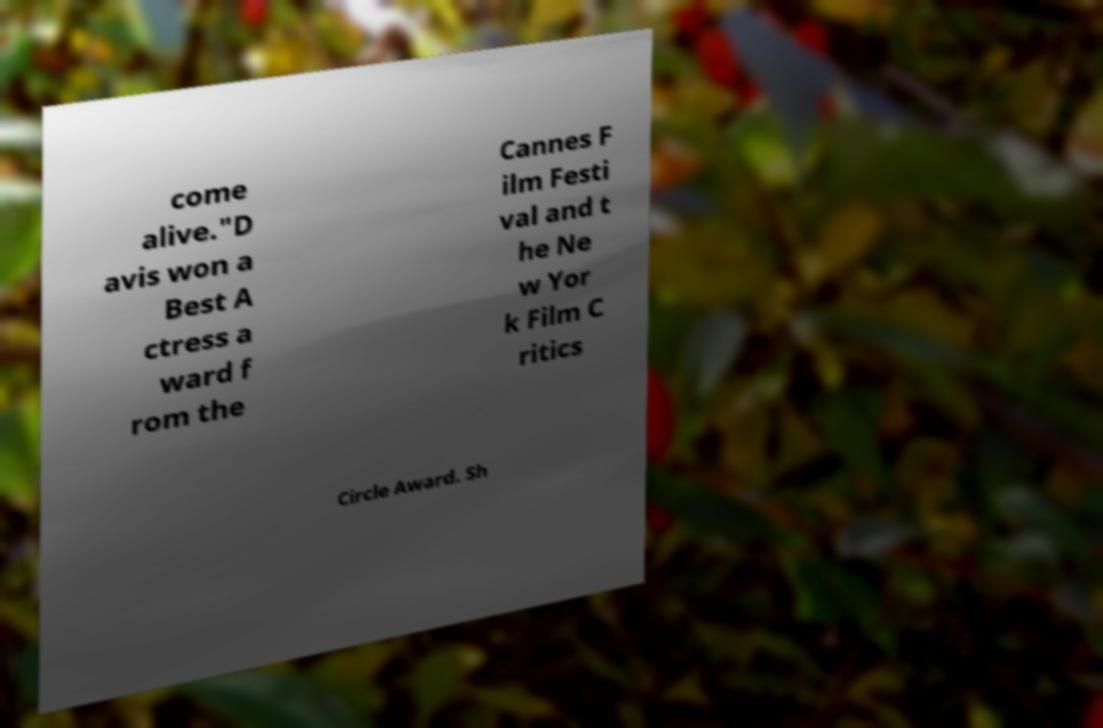Please identify and transcribe the text found in this image. come alive."D avis won a Best A ctress a ward f rom the Cannes F ilm Festi val and t he Ne w Yor k Film C ritics Circle Award. Sh 